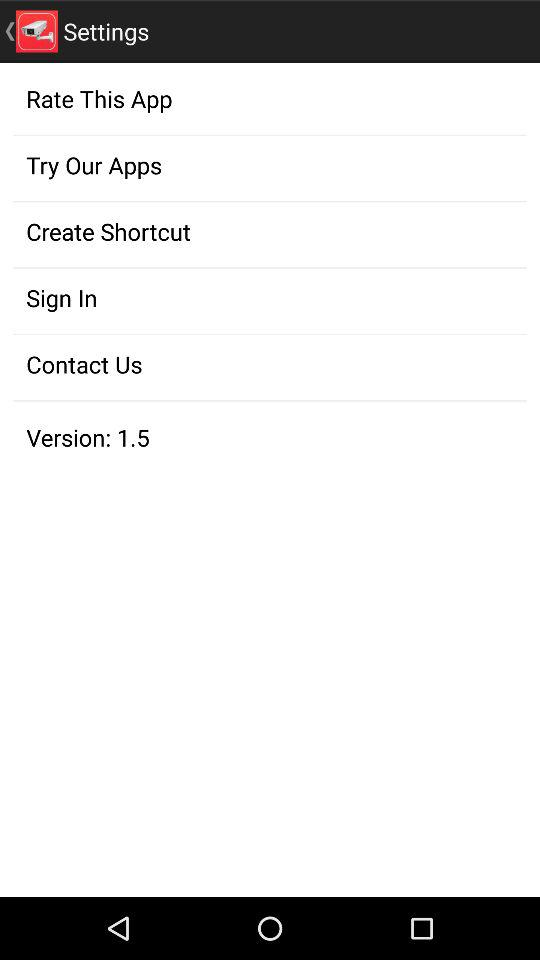What is the version of the application? The version of the application is 1.5. 